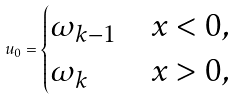<formula> <loc_0><loc_0><loc_500><loc_500>u _ { 0 } = \begin{cases} \omega _ { k - 1 } & x < 0 , \\ \omega _ { k } & x > 0 , \end{cases}</formula> 